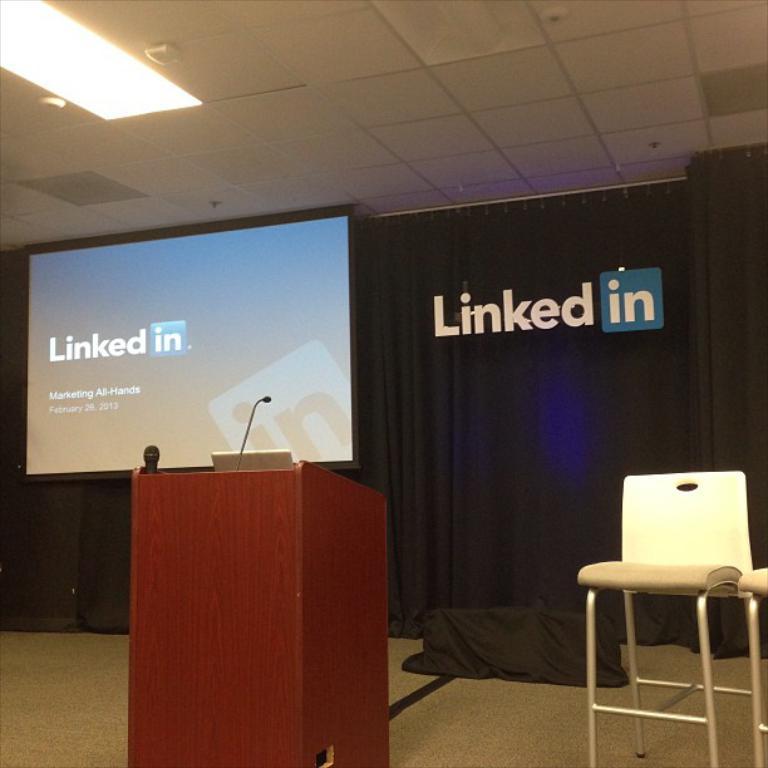Can you describe this image briefly? On the right side there is a stool, in the middle there is the podium, microphone. On the left side there is the projector screen, at the top there is a ceiling light. 